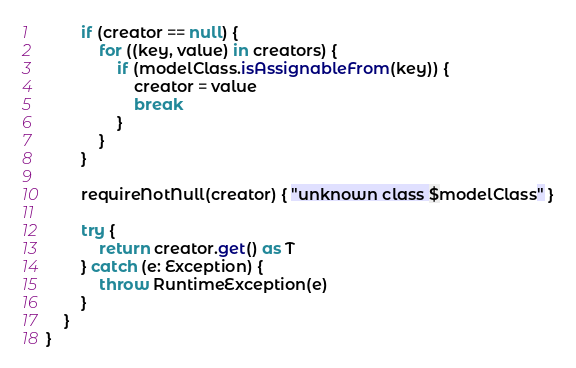Convert code to text. <code><loc_0><loc_0><loc_500><loc_500><_Kotlin_>        if (creator == null) {
            for ((key, value) in creators) {
                if (modelClass.isAssignableFrom(key)) {
                    creator = value
                    break
                }
            }
        }

        requireNotNull(creator) { "unknown class $modelClass" }

        try {
            return creator.get() as T
        } catch (e: Exception) {
            throw RuntimeException(e)
        }
    }
}</code> 